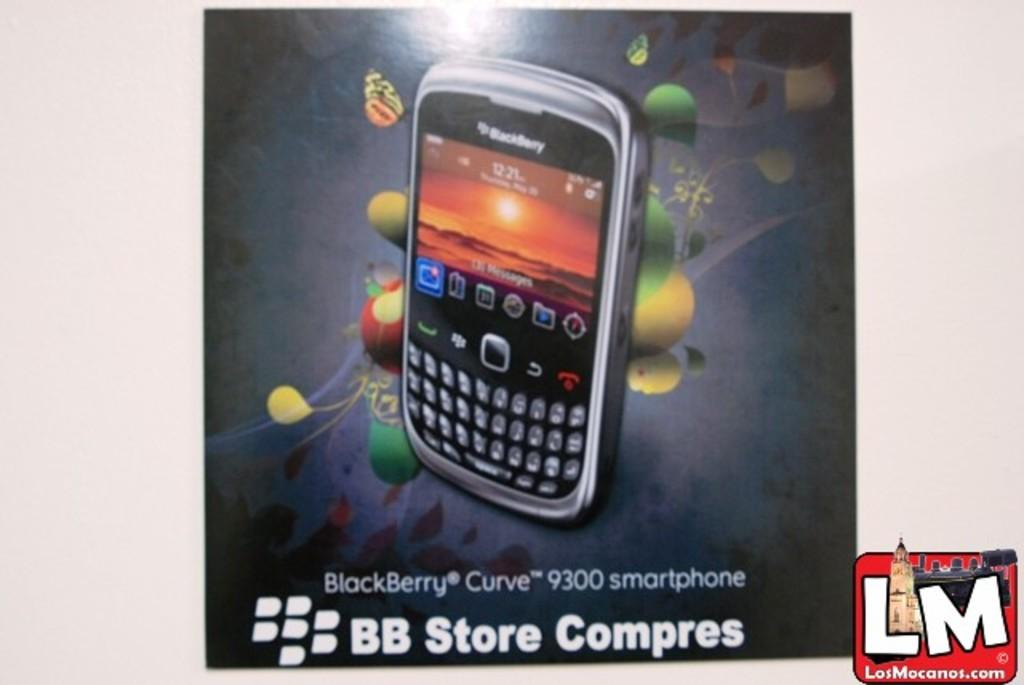<image>
Render a clear and concise summary of the photo. A poster with a Blackberry Curve 9300 Smartphone on it 